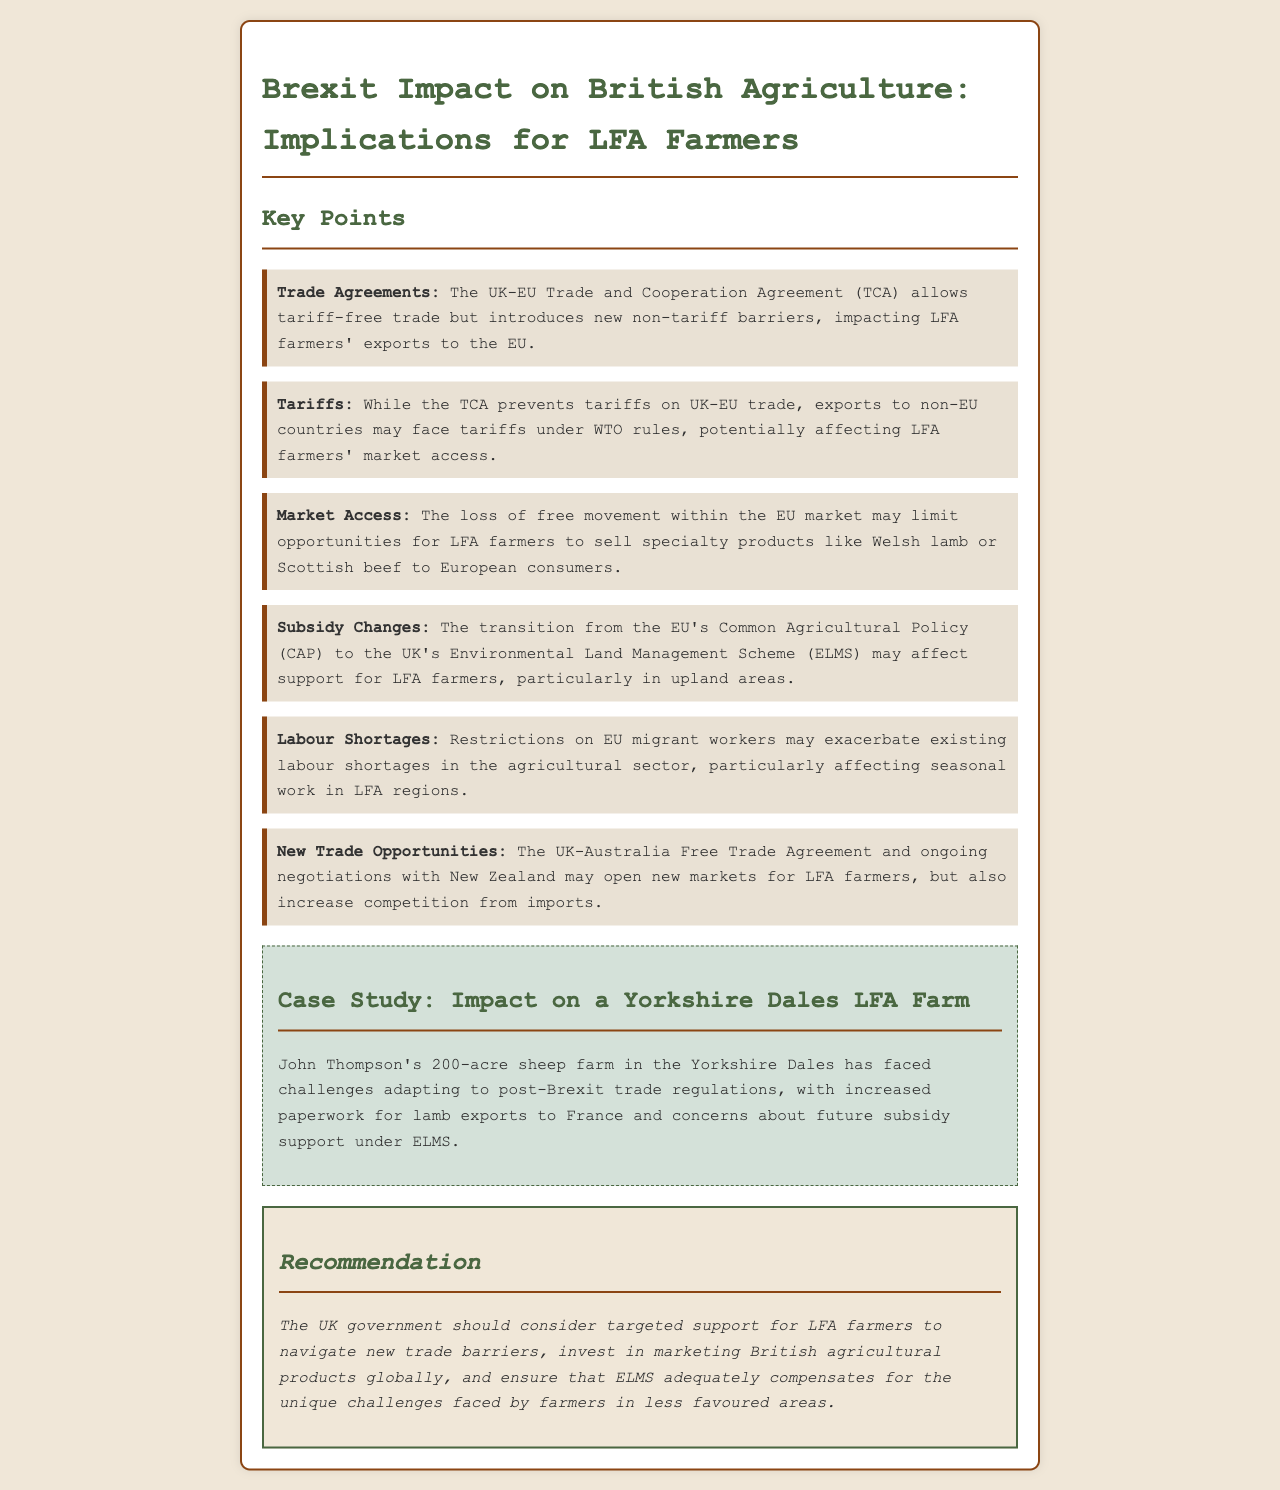What is the Trade Agreement mentioned? The document refers to the UK-EU Trade and Cooperation Agreement (TCA), which impacts trade.
Answer: UK-EU Trade and Cooperation Agreement (TCA) What does TCA prevent on UK-EU trade? The TCA allows for tariff-free trade.
Answer: Tariffs What major change is affecting subsidies for LFA farmers? The transition from the EU's Common Agricultural Policy (CAP) to the UK's Environmental Land Management Scheme (ELMS) affects subsidies.
Answer: ELMS What type of workers may face restrictions? Seasonal agriculture may face restrictions on EU migrant workers.
Answer: EU migrant workers What type of trade may become accessible for LFA farmers? The ongoing negotiations with New Zealand may provide new trade opportunities.
Answer: New Zealand How many acres is John Thompson's farm? John Thompson's farm is 200 acres.
Answer: 200 acres What is the case study location in the document? The case study is focused on a farm in the Yorkshire Dales.
Answer: Yorkshire Dales What should the UK government consider for LFA farmers? The recommendation suggests targeted support for LFA farmers to navigate new trade barriers.
Answer: Targeted support 